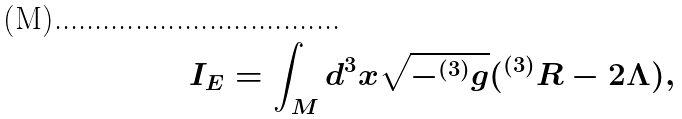<formula> <loc_0><loc_0><loc_500><loc_500>I _ { E } = \int _ { M } d ^ { 3 } x \sqrt { - ^ { ( 3 ) } g } ( ^ { ( 3 ) } R - 2 \Lambda ) ,</formula> 